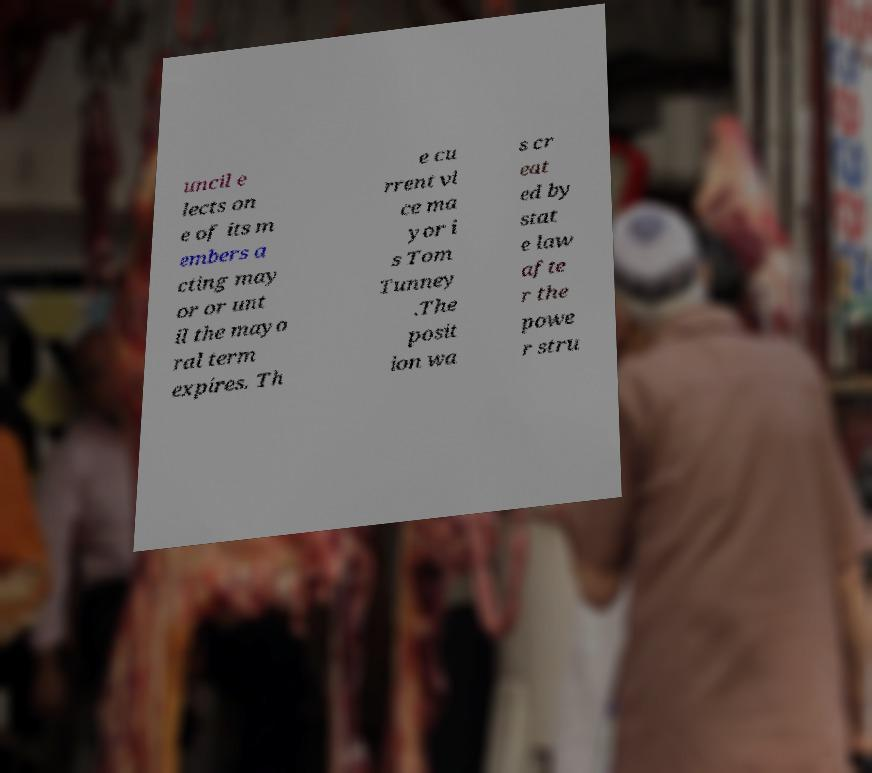Can you accurately transcribe the text from the provided image for me? uncil e lects on e of its m embers a cting may or or unt il the mayo ral term expires. Th e cu rrent vi ce ma yor i s Tom Tunney .The posit ion wa s cr eat ed by stat e law afte r the powe r stru 